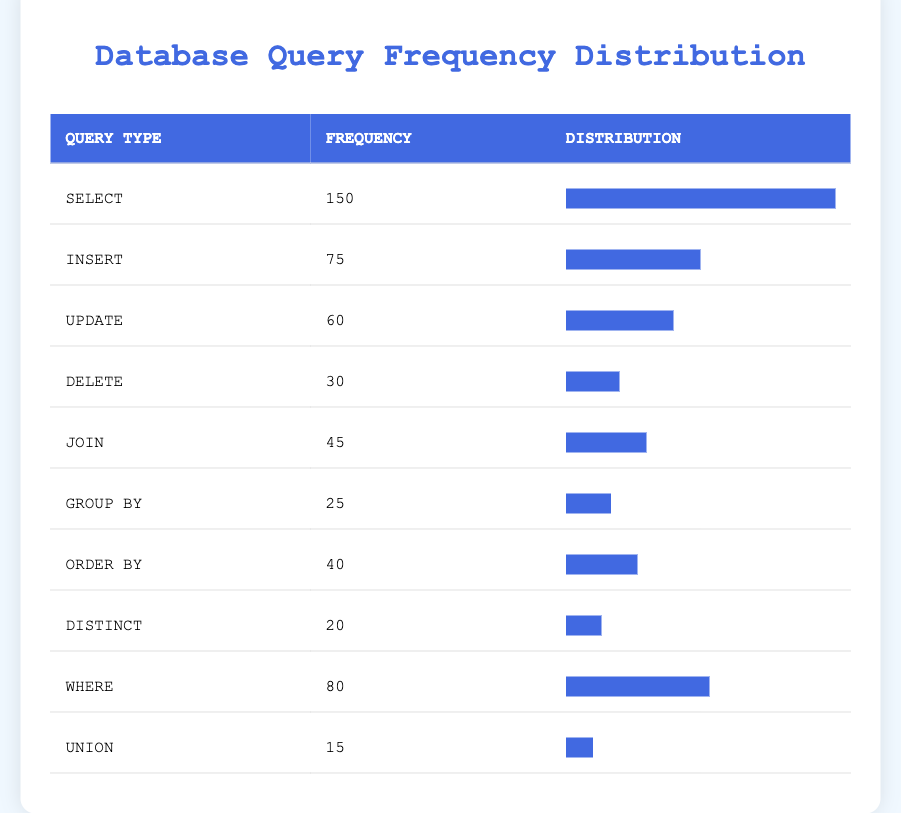What is the frequency of the SELECT query type? According to the table, the frequency for the SELECT query type is listed directly as 150.
Answer: 150 Which query type has the lowest frequency? From the table, the UNION query type has the lowest frequency listed at 15.
Answer: UNION What is the combined frequency of INSERT and UPDATE query types? The frequency for INSERT is 75 and for UPDATE is 60. Adding these gives 75 + 60 = 135.
Answer: 135 Is the frequency of JOIN greater than the frequency of ORDER BY? The frequency for JOIN is 45 and for ORDER BY is 40. Since 45 is greater than 40, the statement is true.
Answer: Yes What is the average frequency of all query types? To find the average, first sum all frequencies: 150 + 75 + 60 + 30 + 45 + 25 + 40 + 20 + 80 + 15 = 525. There are 10 query types, so the average is 525 / 10 = 52.5.
Answer: 52.5 How many more times frequent is SELECT compared to DELETE? The frequency of SELECT is 150 and DELETE is 30. To find the ratio, subtract DELETE from SELECT: 150 - 30 = 120, then compare: SELECT is 5 times more frequent than DELETE.
Answer: 5 times Is the frequency of DISTINCT greater than the frequency of GROUP BY? From the table, DISTINCT has a frequency of 20, while GROUP BY has a frequency of 25. Since 20 is not greater than 25, the statement is false.
Answer: No What percentage of queries are WHERE compared to the total frequency? To find the percentage, divide the frequency of WHERE (80) by the total frequency (525), then multiply by 100: (80 / 525) * 100 = 15.24%.
Answer: 15.24% If we combine the frequencies of DELETE, GROUP BY, and UNION, what is the result? The frequency for DELETE is 30, GROUP BY is 25, and UNION is 15. Summing them gives: 30 + 25 + 15 = 70.
Answer: 70 